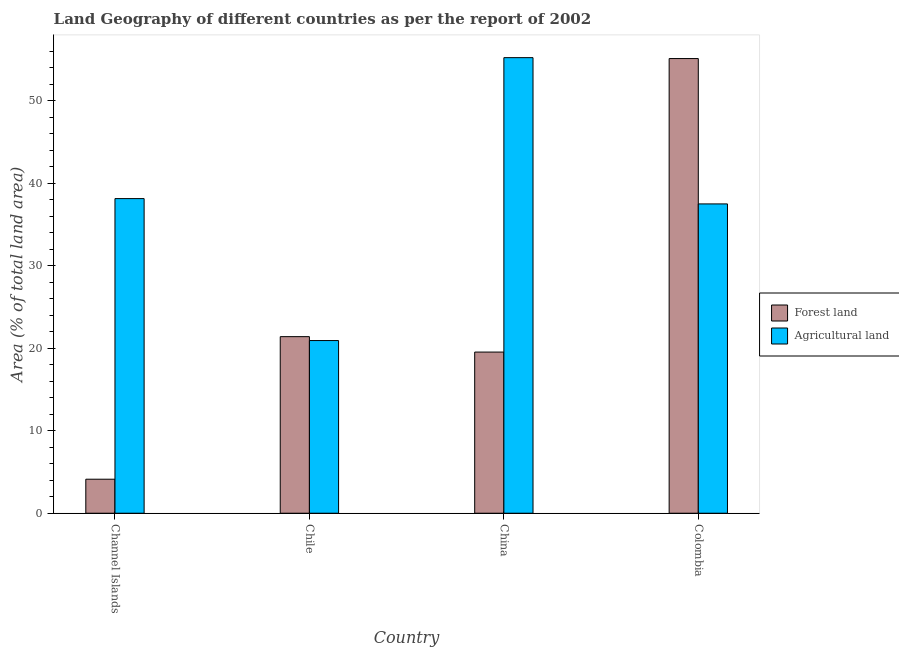How many different coloured bars are there?
Provide a short and direct response. 2. Are the number of bars per tick equal to the number of legend labels?
Ensure brevity in your answer.  Yes. How many bars are there on the 2nd tick from the left?
Offer a very short reply. 2. What is the label of the 1st group of bars from the left?
Offer a very short reply. Channel Islands. In how many cases, is the number of bars for a given country not equal to the number of legend labels?
Give a very brief answer. 0. What is the percentage of land area under forests in Channel Islands?
Your response must be concise. 4.12. Across all countries, what is the maximum percentage of land area under agriculture?
Offer a very short reply. 55.23. Across all countries, what is the minimum percentage of land area under forests?
Make the answer very short. 4.12. In which country was the percentage of land area under forests minimum?
Give a very brief answer. Channel Islands. What is the total percentage of land area under agriculture in the graph?
Provide a short and direct response. 151.81. What is the difference between the percentage of land area under agriculture in Channel Islands and that in Chile?
Give a very brief answer. 17.21. What is the difference between the percentage of land area under forests in China and the percentage of land area under agriculture in Channel Islands?
Ensure brevity in your answer.  -18.61. What is the average percentage of land area under forests per country?
Your response must be concise. 25.05. What is the difference between the percentage of land area under forests and percentage of land area under agriculture in Chile?
Offer a terse response. 0.47. What is the ratio of the percentage of land area under forests in Channel Islands to that in Colombia?
Your answer should be very brief. 0.07. Is the difference between the percentage of land area under forests in China and Colombia greater than the difference between the percentage of land area under agriculture in China and Colombia?
Ensure brevity in your answer.  No. What is the difference between the highest and the second highest percentage of land area under forests?
Provide a short and direct response. 33.72. What is the difference between the highest and the lowest percentage of land area under agriculture?
Provide a succinct answer. 34.3. Is the sum of the percentage of land area under forests in Channel Islands and China greater than the maximum percentage of land area under agriculture across all countries?
Keep it short and to the point. No. What does the 1st bar from the left in Chile represents?
Your answer should be very brief. Forest land. What does the 2nd bar from the right in Colombia represents?
Offer a terse response. Forest land. How many bars are there?
Your answer should be compact. 8. Are all the bars in the graph horizontal?
Offer a terse response. No. How many countries are there in the graph?
Your answer should be very brief. 4. Are the values on the major ticks of Y-axis written in scientific E-notation?
Give a very brief answer. No. Where does the legend appear in the graph?
Offer a very short reply. Center right. What is the title of the graph?
Offer a very short reply. Land Geography of different countries as per the report of 2002. Does "Domestic Liabilities" appear as one of the legend labels in the graph?
Ensure brevity in your answer.  No. What is the label or title of the Y-axis?
Offer a very short reply. Area (% of total land area). What is the Area (% of total land area) in Forest land in Channel Islands?
Your answer should be compact. 4.12. What is the Area (% of total land area) of Agricultural land in Channel Islands?
Your answer should be compact. 38.14. What is the Area (% of total land area) in Forest land in Chile?
Provide a short and direct response. 21.41. What is the Area (% of total land area) in Agricultural land in Chile?
Your answer should be very brief. 20.93. What is the Area (% of total land area) in Forest land in China?
Offer a terse response. 19.54. What is the Area (% of total land area) of Agricultural land in China?
Offer a very short reply. 55.23. What is the Area (% of total land area) in Forest land in Colombia?
Offer a terse response. 55.12. What is the Area (% of total land area) in Agricultural land in Colombia?
Your answer should be very brief. 37.5. Across all countries, what is the maximum Area (% of total land area) of Forest land?
Ensure brevity in your answer.  55.12. Across all countries, what is the maximum Area (% of total land area) in Agricultural land?
Give a very brief answer. 55.23. Across all countries, what is the minimum Area (% of total land area) of Forest land?
Give a very brief answer. 4.12. Across all countries, what is the minimum Area (% of total land area) in Agricultural land?
Ensure brevity in your answer.  20.93. What is the total Area (% of total land area) of Forest land in the graph?
Your answer should be compact. 100.19. What is the total Area (% of total land area) in Agricultural land in the graph?
Offer a very short reply. 151.81. What is the difference between the Area (% of total land area) in Forest land in Channel Islands and that in Chile?
Offer a very short reply. -17.28. What is the difference between the Area (% of total land area) of Agricultural land in Channel Islands and that in Chile?
Make the answer very short. 17.21. What is the difference between the Area (% of total land area) in Forest land in Channel Islands and that in China?
Your response must be concise. -15.41. What is the difference between the Area (% of total land area) in Agricultural land in Channel Islands and that in China?
Keep it short and to the point. -17.09. What is the difference between the Area (% of total land area) of Forest land in Channel Islands and that in Colombia?
Give a very brief answer. -51. What is the difference between the Area (% of total land area) of Agricultural land in Channel Islands and that in Colombia?
Provide a short and direct response. 0.64. What is the difference between the Area (% of total land area) in Forest land in Chile and that in China?
Provide a succinct answer. 1.87. What is the difference between the Area (% of total land area) of Agricultural land in Chile and that in China?
Give a very brief answer. -34.3. What is the difference between the Area (% of total land area) in Forest land in Chile and that in Colombia?
Provide a succinct answer. -33.72. What is the difference between the Area (% of total land area) in Agricultural land in Chile and that in Colombia?
Your answer should be very brief. -16.57. What is the difference between the Area (% of total land area) in Forest land in China and that in Colombia?
Offer a terse response. -35.59. What is the difference between the Area (% of total land area) of Agricultural land in China and that in Colombia?
Your response must be concise. 17.73. What is the difference between the Area (% of total land area) in Forest land in Channel Islands and the Area (% of total land area) in Agricultural land in Chile?
Offer a terse response. -16.81. What is the difference between the Area (% of total land area) in Forest land in Channel Islands and the Area (% of total land area) in Agricultural land in China?
Your answer should be compact. -51.11. What is the difference between the Area (% of total land area) of Forest land in Channel Islands and the Area (% of total land area) of Agricultural land in Colombia?
Ensure brevity in your answer.  -33.38. What is the difference between the Area (% of total land area) of Forest land in Chile and the Area (% of total land area) of Agricultural land in China?
Your answer should be compact. -33.82. What is the difference between the Area (% of total land area) of Forest land in Chile and the Area (% of total land area) of Agricultural land in Colombia?
Your response must be concise. -16.09. What is the difference between the Area (% of total land area) of Forest land in China and the Area (% of total land area) of Agricultural land in Colombia?
Offer a terse response. -17.96. What is the average Area (% of total land area) of Forest land per country?
Your response must be concise. 25.05. What is the average Area (% of total land area) of Agricultural land per country?
Keep it short and to the point. 37.95. What is the difference between the Area (% of total land area) of Forest land and Area (% of total land area) of Agricultural land in Channel Islands?
Give a very brief answer. -34.02. What is the difference between the Area (% of total land area) in Forest land and Area (% of total land area) in Agricultural land in Chile?
Offer a terse response. 0.47. What is the difference between the Area (% of total land area) of Forest land and Area (% of total land area) of Agricultural land in China?
Provide a short and direct response. -35.7. What is the difference between the Area (% of total land area) in Forest land and Area (% of total land area) in Agricultural land in Colombia?
Offer a very short reply. 17.62. What is the ratio of the Area (% of total land area) in Forest land in Channel Islands to that in Chile?
Your answer should be compact. 0.19. What is the ratio of the Area (% of total land area) of Agricultural land in Channel Islands to that in Chile?
Offer a very short reply. 1.82. What is the ratio of the Area (% of total land area) of Forest land in Channel Islands to that in China?
Ensure brevity in your answer.  0.21. What is the ratio of the Area (% of total land area) of Agricultural land in Channel Islands to that in China?
Offer a very short reply. 0.69. What is the ratio of the Area (% of total land area) in Forest land in Channel Islands to that in Colombia?
Your response must be concise. 0.07. What is the ratio of the Area (% of total land area) in Agricultural land in Channel Islands to that in Colombia?
Offer a terse response. 1.02. What is the ratio of the Area (% of total land area) of Forest land in Chile to that in China?
Your answer should be compact. 1.1. What is the ratio of the Area (% of total land area) of Agricultural land in Chile to that in China?
Offer a very short reply. 0.38. What is the ratio of the Area (% of total land area) of Forest land in Chile to that in Colombia?
Ensure brevity in your answer.  0.39. What is the ratio of the Area (% of total land area) in Agricultural land in Chile to that in Colombia?
Offer a terse response. 0.56. What is the ratio of the Area (% of total land area) in Forest land in China to that in Colombia?
Offer a terse response. 0.35. What is the ratio of the Area (% of total land area) in Agricultural land in China to that in Colombia?
Your response must be concise. 1.47. What is the difference between the highest and the second highest Area (% of total land area) in Forest land?
Provide a succinct answer. 33.72. What is the difference between the highest and the second highest Area (% of total land area) of Agricultural land?
Your answer should be very brief. 17.09. What is the difference between the highest and the lowest Area (% of total land area) of Forest land?
Keep it short and to the point. 51. What is the difference between the highest and the lowest Area (% of total land area) in Agricultural land?
Make the answer very short. 34.3. 